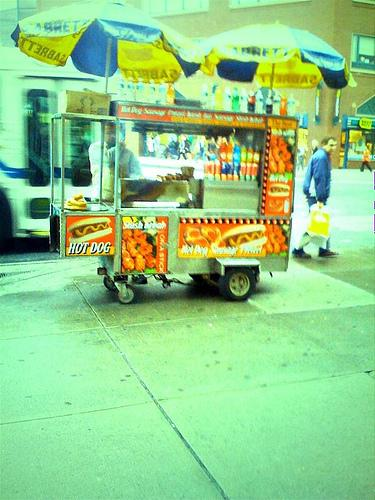What type of food is advertised on the cart? hot dog 